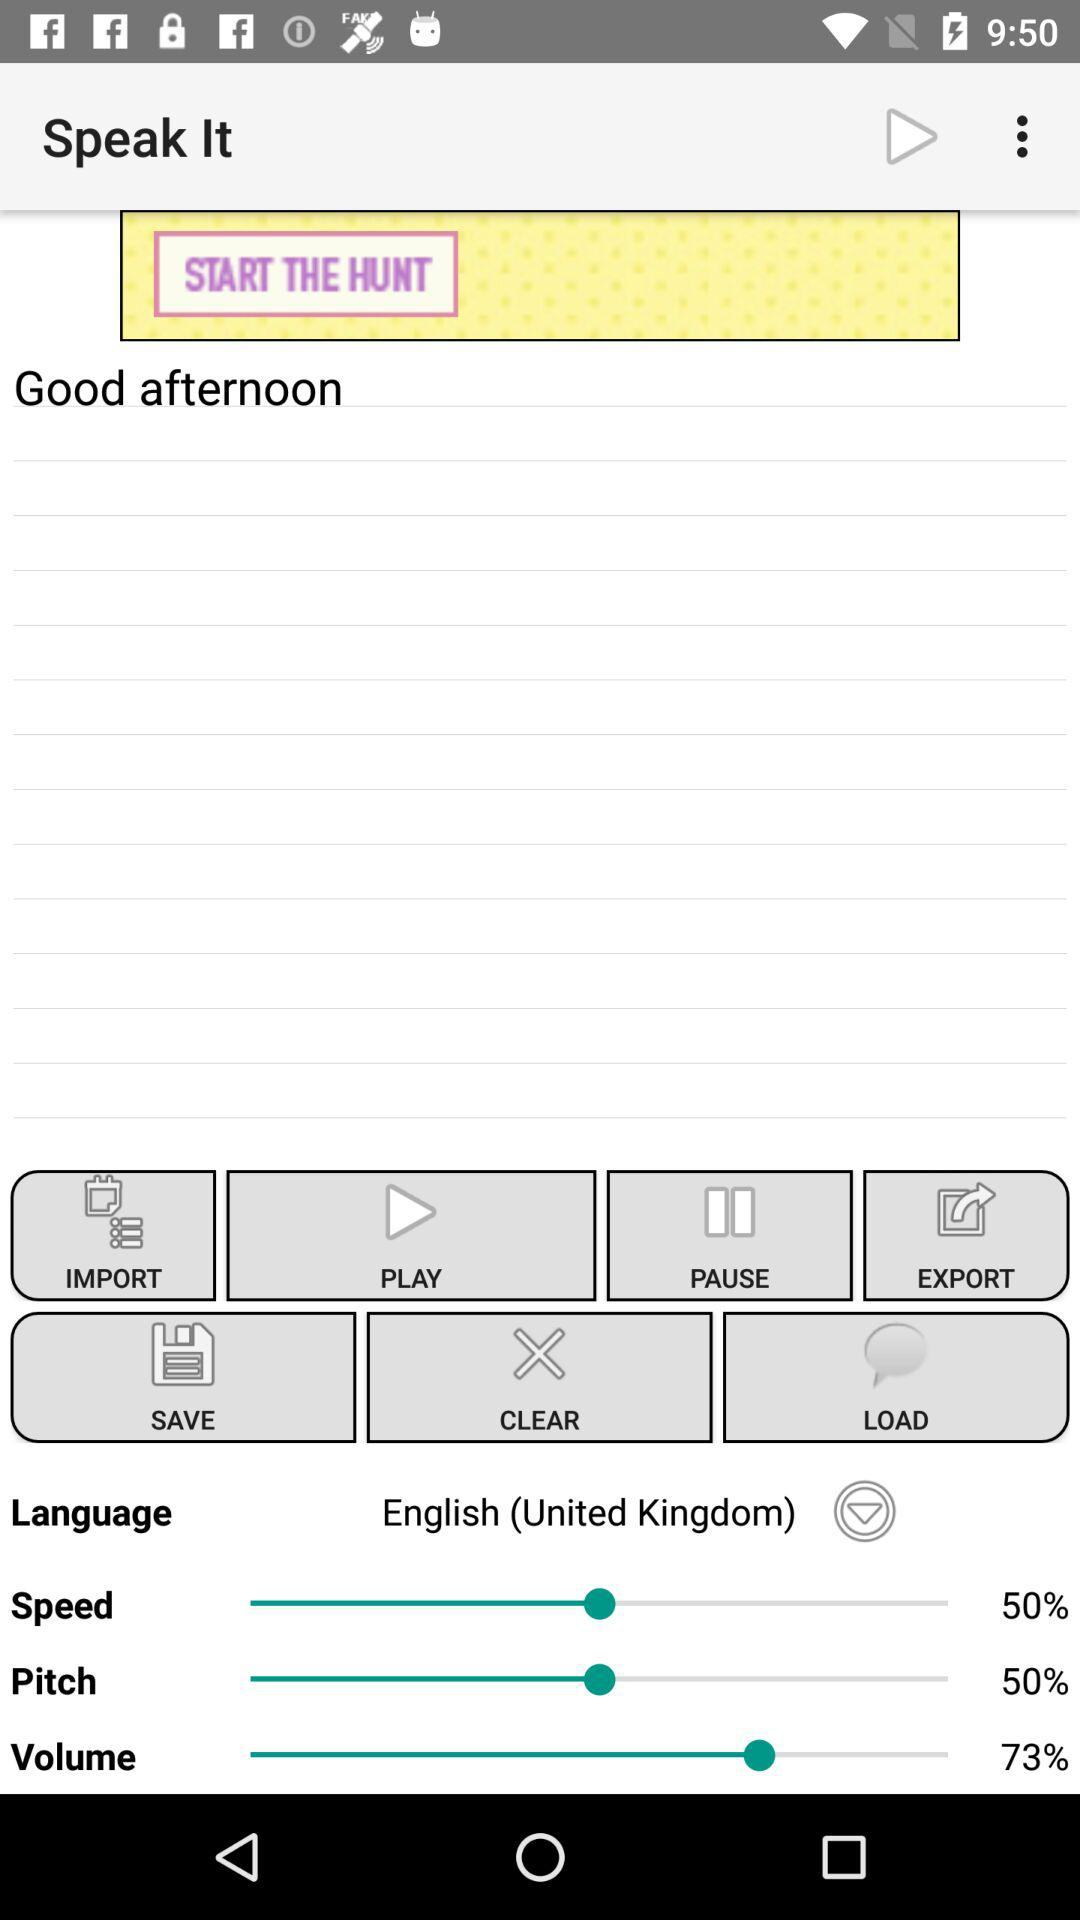Which language was selected? The selected language was English (United Kingdom). 